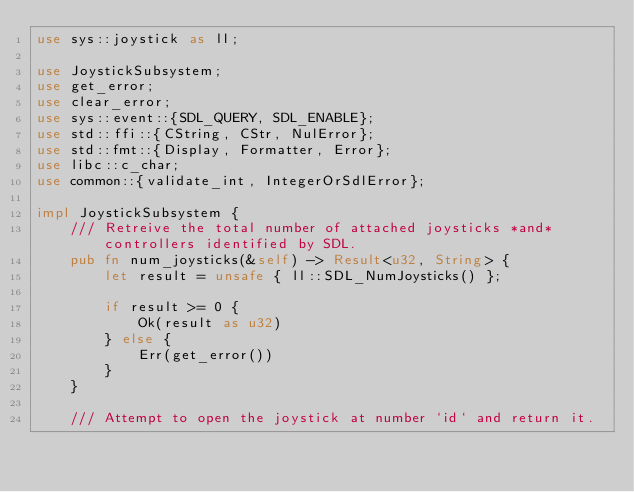<code> <loc_0><loc_0><loc_500><loc_500><_Rust_>use sys::joystick as ll;

use JoystickSubsystem;
use get_error;
use clear_error;
use sys::event::{SDL_QUERY, SDL_ENABLE};
use std::ffi::{CString, CStr, NulError};
use std::fmt::{Display, Formatter, Error};
use libc::c_char;
use common::{validate_int, IntegerOrSdlError};

impl JoystickSubsystem {
    /// Retreive the total number of attached joysticks *and* controllers identified by SDL.
    pub fn num_joysticks(&self) -> Result<u32, String> {
        let result = unsafe { ll::SDL_NumJoysticks() };

        if result >= 0 {
            Ok(result as u32)
        } else {
            Err(get_error())
        }
    }

    /// Attempt to open the joystick at number `id` and return it.</code> 